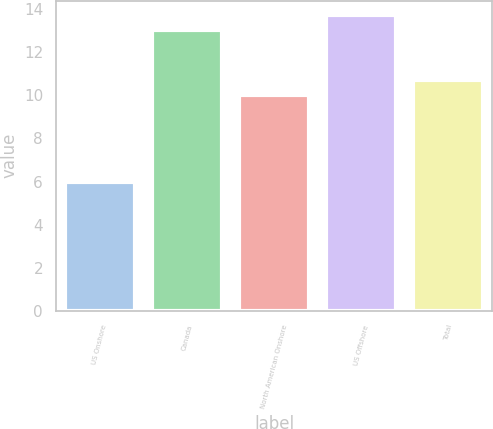Convert chart. <chart><loc_0><loc_0><loc_500><loc_500><bar_chart><fcel>US Onshore<fcel>Canada<fcel>North American Onshore<fcel>US Offshore<fcel>Total<nl><fcel>6<fcel>13<fcel>10<fcel>13.7<fcel>10.7<nl></chart> 